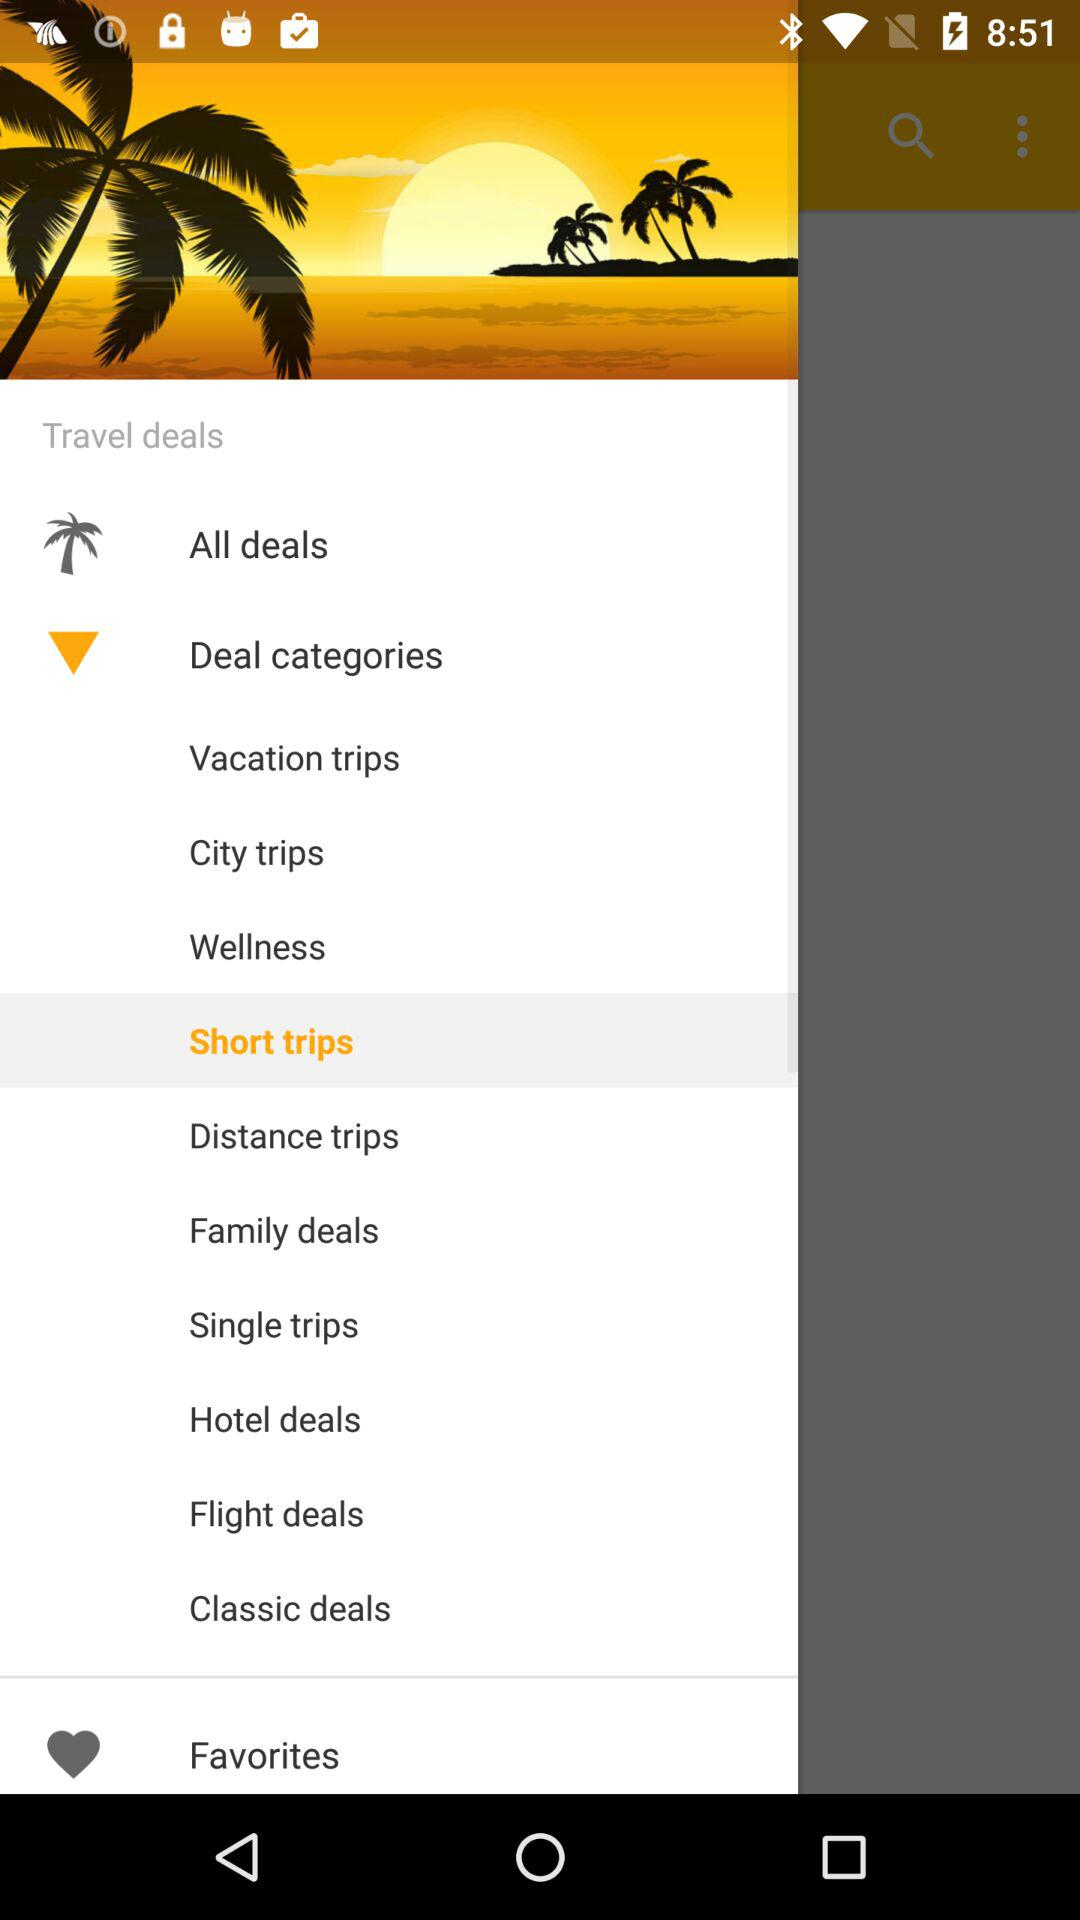How many deal categories are there?
Answer the question using a single word or phrase. 10 